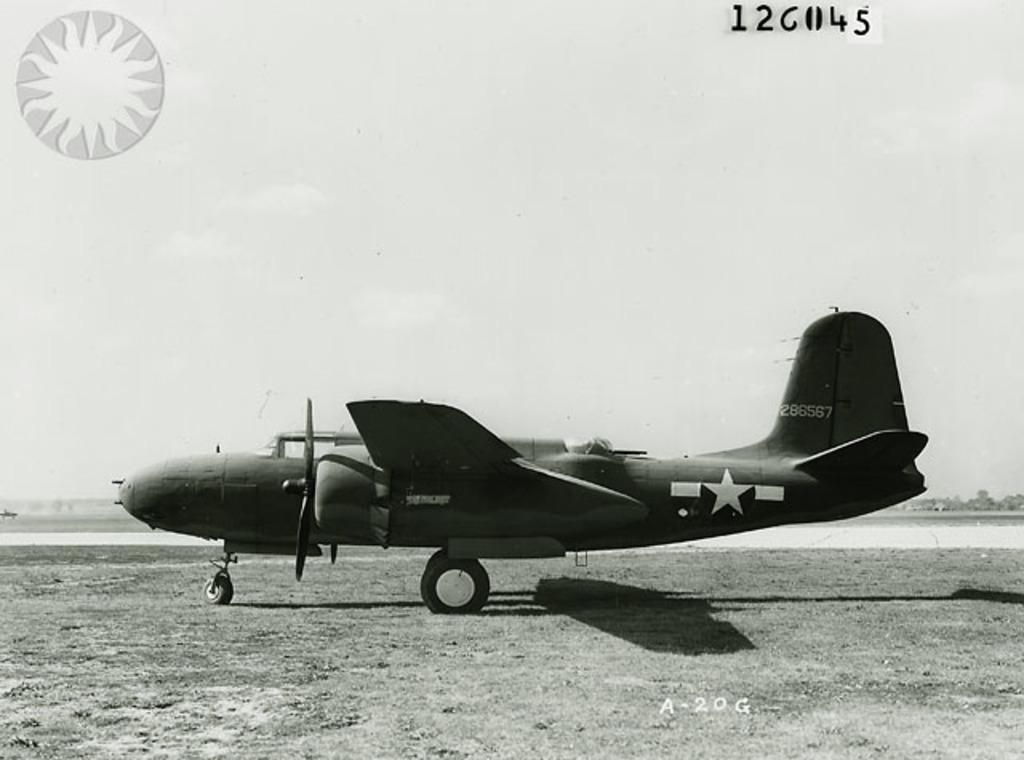What is the number on the tail of this plane?
Your response must be concise. 286567. What identification number is written on the bottom of photo in white?
Offer a very short reply. A-20g. 